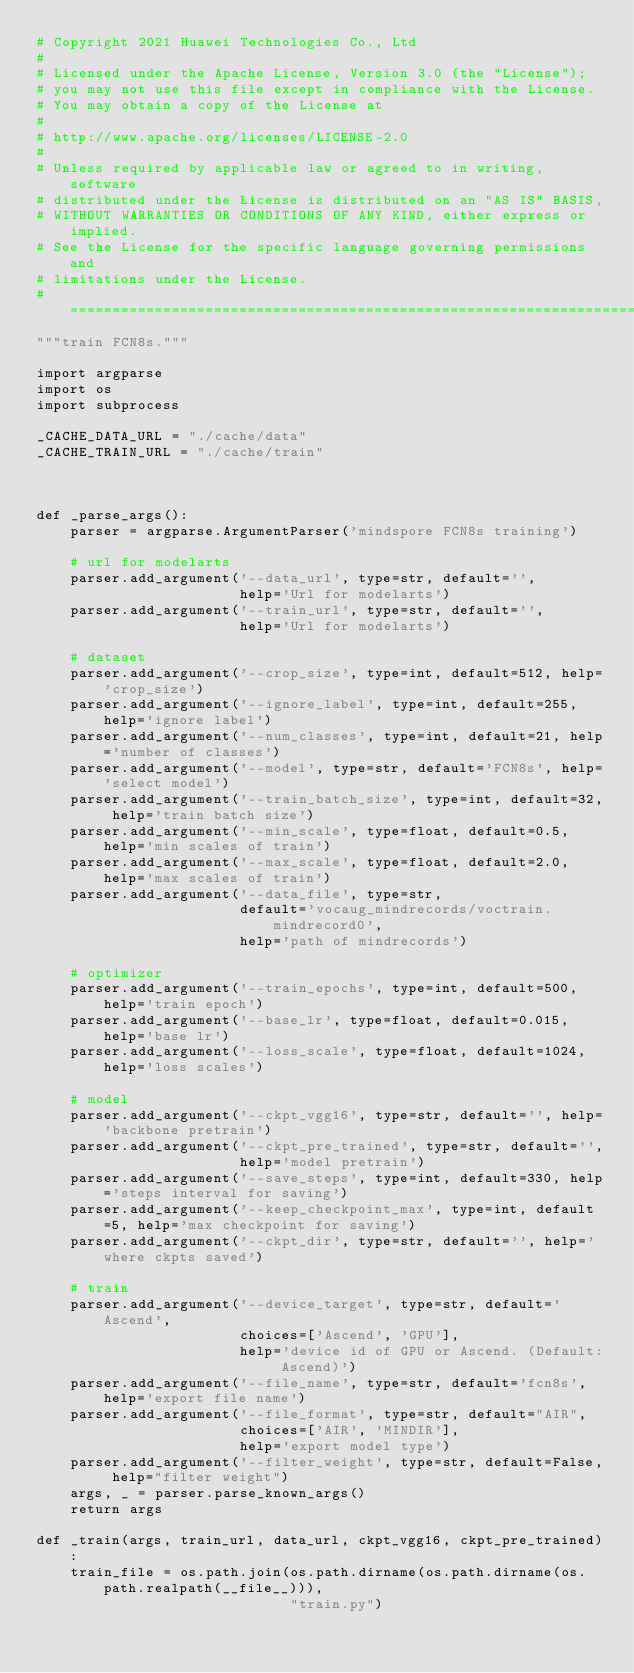<code> <loc_0><loc_0><loc_500><loc_500><_Python_># Copyright 2021 Huawei Technologies Co., Ltd
#
# Licensed under the Apache License, Version 3.0 (the "License");
# you may not use this file except in compliance with the License.
# You may obtain a copy of the License at
#
# http://www.apache.org/licenses/LICENSE-2.0
#
# Unless required by applicable law or agreed to in writing, software
# distributed under the License is distributed on an "AS IS" BASIS,
# WITHOUT WARRANTIES OR CONDITIONS OF ANY KIND, either express or implied.
# See the License for the specific language governing permissions and
# limitations under the License.
# ============================================================================
"""train FCN8s."""

import argparse
import os
import subprocess

_CACHE_DATA_URL = "./cache/data"
_CACHE_TRAIN_URL = "./cache/train"



def _parse_args():
    parser = argparse.ArgumentParser('mindspore FCN8s training')

    # url for modelarts
    parser.add_argument('--data_url', type=str, default='',
                        help='Url for modelarts')
    parser.add_argument('--train_url', type=str, default='',
                        help='Url for modelarts')

    # dataset
    parser.add_argument('--crop_size', type=int, default=512, help='crop_size')
    parser.add_argument('--ignore_label', type=int, default=255, help='ignore label')
    parser.add_argument('--num_classes', type=int, default=21, help='number of classes')
    parser.add_argument('--model', type=str, default='FCN8s', help='select model')
    parser.add_argument('--train_batch_size', type=int, default=32, help='train batch size')
    parser.add_argument('--min_scale', type=float, default=0.5, help='min scales of train')
    parser.add_argument('--max_scale', type=float, default=2.0, help='max scales of train')
    parser.add_argument('--data_file', type=str,
                        default='vocaug_mindrecords/voctrain.mindrecord0',
                        help='path of mindrecords')

    # optimizer
    parser.add_argument('--train_epochs', type=int, default=500, help='train epoch')
    parser.add_argument('--base_lr', type=float, default=0.015, help='base lr')
    parser.add_argument('--loss_scale', type=float, default=1024, help='loss scales')

    # model
    parser.add_argument('--ckpt_vgg16', type=str, default='', help='backbone pretrain')
    parser.add_argument('--ckpt_pre_trained', type=str, default='',
                        help='model pretrain')
    parser.add_argument('--save_steps', type=int, default=330, help='steps interval for saving')
    parser.add_argument('--keep_checkpoint_max', type=int, default=5, help='max checkpoint for saving')
    parser.add_argument('--ckpt_dir', type=str, default='', help='where ckpts saved')

    # train
    parser.add_argument('--device_target', type=str, default='Ascend',
                        choices=['Ascend', 'GPU'],
                        help='device id of GPU or Ascend. (Default: Ascend)')
    parser.add_argument('--file_name', type=str, default='fcn8s', help='export file name')
    parser.add_argument('--file_format', type=str, default="AIR",
                        choices=['AIR', 'MINDIR'],
                        help='export model type')
    parser.add_argument('--filter_weight', type=str, default=False, help="filter weight")
    args, _ = parser.parse_known_args()
    return args

def _train(args, train_url, data_url, ckpt_vgg16, ckpt_pre_trained):
    train_file = os.path.join(os.path.dirname(os.path.dirname(os.path.realpath(__file__))),
                              "train.py")</code> 